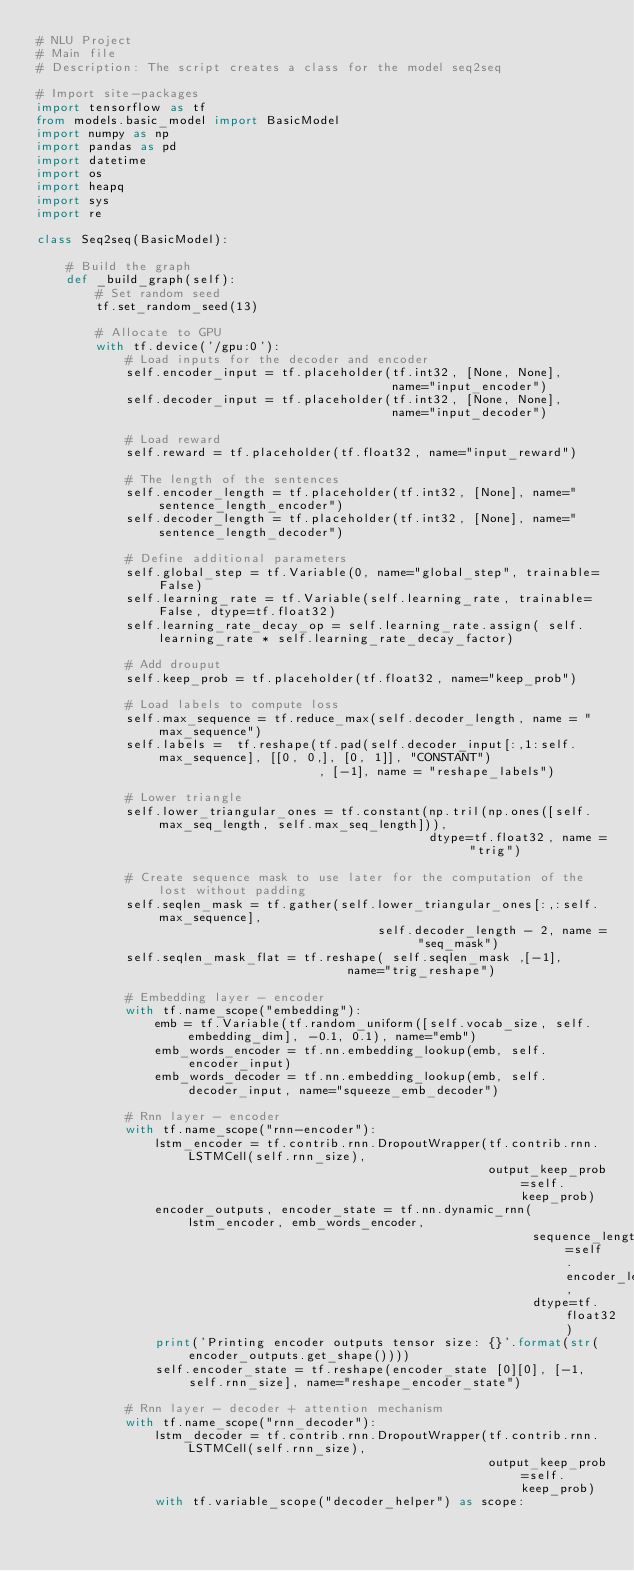<code> <loc_0><loc_0><loc_500><loc_500><_Python_># NLU Project
# Main file
# Description: The script creates a class for the model seq2seq

# Import site-packages
import tensorflow as tf
from models.basic_model import BasicModel
import numpy as np
import pandas as pd
import datetime
import os
import heapq
import sys
import re

class Seq2seq(BasicModel):

    # Build the graph
    def _build_graph(self):
        # Set random seed
        tf.set_random_seed(13)

        # Allocate to GPU
        with tf.device('/gpu:0'):
            # Load inputs for the decoder and encoder
            self.encoder_input = tf.placeholder(tf.int32, [None, None],
                                                name="input_encoder")
            self.decoder_input = tf.placeholder(tf.int32, [None, None],
                                                name="input_decoder")

            # Load reward
            self.reward = tf.placeholder(tf.float32, name="input_reward")

            # The length of the sentences
            self.encoder_length = tf.placeholder(tf.int32, [None], name="sentence_length_encoder")
            self.decoder_length = tf.placeholder(tf.int32, [None], name="sentence_length_decoder")

            # Define additional parameters
            self.global_step = tf.Variable(0, name="global_step", trainable=False)
            self.learning_rate = tf.Variable(self.learning_rate, trainable=False, dtype=tf.float32)
            self.learning_rate_decay_op = self.learning_rate.assign( self.learning_rate * self.learning_rate_decay_factor)

            # Add drouput
            self.keep_prob = tf.placeholder(tf.float32, name="keep_prob")

            # Load labels to compute loss
            self.max_sequence = tf.reduce_max(self.decoder_length, name = "max_sequence")
            self.labels =  tf.reshape(tf.pad(self.decoder_input[:,1:self.max_sequence], [[0, 0,], [0, 1]], "CONSTANT")
                                      , [-1], name = "reshape_labels")

            # Lower triangle
            self.lower_triangular_ones = tf.constant(np.tril(np.ones([self.max_seq_length, self.max_seq_length])),
                                                     dtype=tf.float32, name = "trig")

            # Create sequence mask to use later for the computation of the lost without padding
            self.seqlen_mask = tf.gather(self.lower_triangular_ones[:,:self.max_sequence],
                                              self.decoder_length - 2, name = "seq_mask")
            self.seqlen_mask_flat = tf.reshape( self.seqlen_mask ,[-1],
                                          name="trig_reshape")

            # Embedding layer - encoder
            with tf.name_scope("embedding"):
                emb = tf.Variable(tf.random_uniform([self.vocab_size, self.embedding_dim], -0.1, 0.1), name="emb")
                emb_words_encoder = tf.nn.embedding_lookup(emb, self.encoder_input)
                emb_words_decoder = tf.nn.embedding_lookup(emb, self.decoder_input, name="squeeze_emb_decoder")

            # Rnn layer - encoder
            with tf.name_scope("rnn-encoder"):
                lstm_encoder = tf.contrib.rnn.DropoutWrapper(tf.contrib.rnn.LSTMCell(self.rnn_size),
                                                             output_keep_prob=self.keep_prob)
                encoder_outputs, encoder_state = tf.nn.dynamic_rnn(lstm_encoder, emb_words_encoder,
                                                                   sequence_length=self.encoder_length,
                                                                   dtype=tf.float32)
                print('Printing encoder outputs tensor size: {}'.format(str(encoder_outputs.get_shape())))
                self.encoder_state = tf.reshape(encoder_state [0][0], [-1, self.rnn_size], name="reshape_encoder_state")

            # Rnn layer - decoder + attention mechanism
            with tf.name_scope("rnn_decoder"):
                lstm_decoder = tf.contrib.rnn.DropoutWrapper(tf.contrib.rnn.LSTMCell(self.rnn_size),
                                                             output_keep_prob=self.keep_prob)
                with tf.variable_scope("decoder_helper") as scope:</code> 